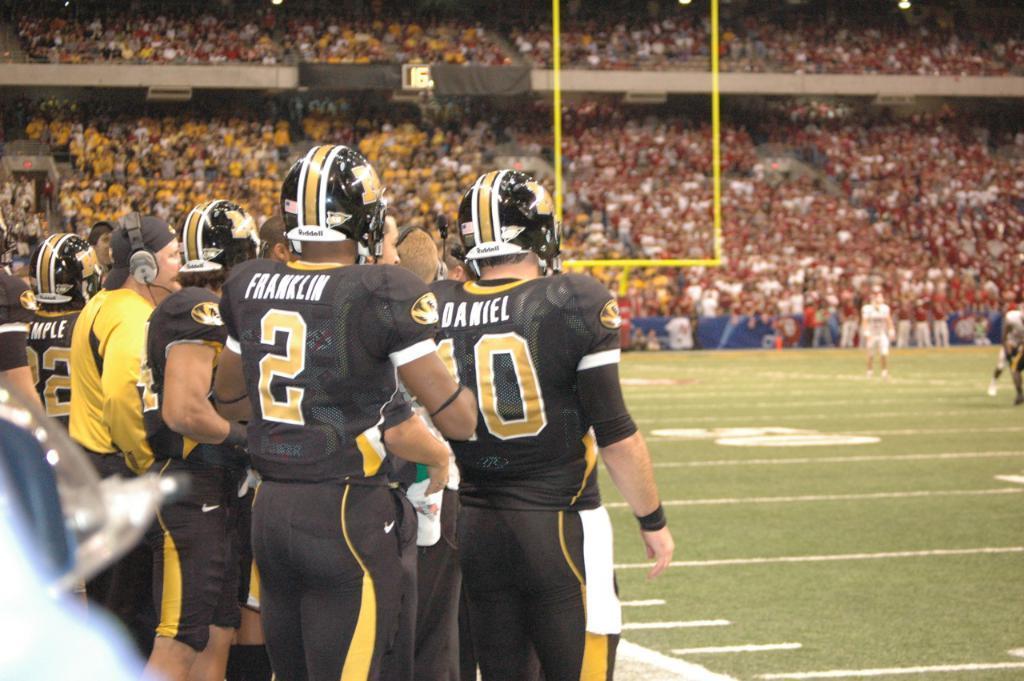In one or two sentences, can you explain what this image depicts? In this picture we can see some people are standing on the left side they wore helmets, at the bottom there is grass, in the background we can see some people, there are some lights at the top of the picture. 